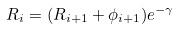<formula> <loc_0><loc_0><loc_500><loc_500>R _ { i } = ( R _ { i + 1 } + \phi _ { i + 1 } ) e ^ { - \gamma }</formula> 